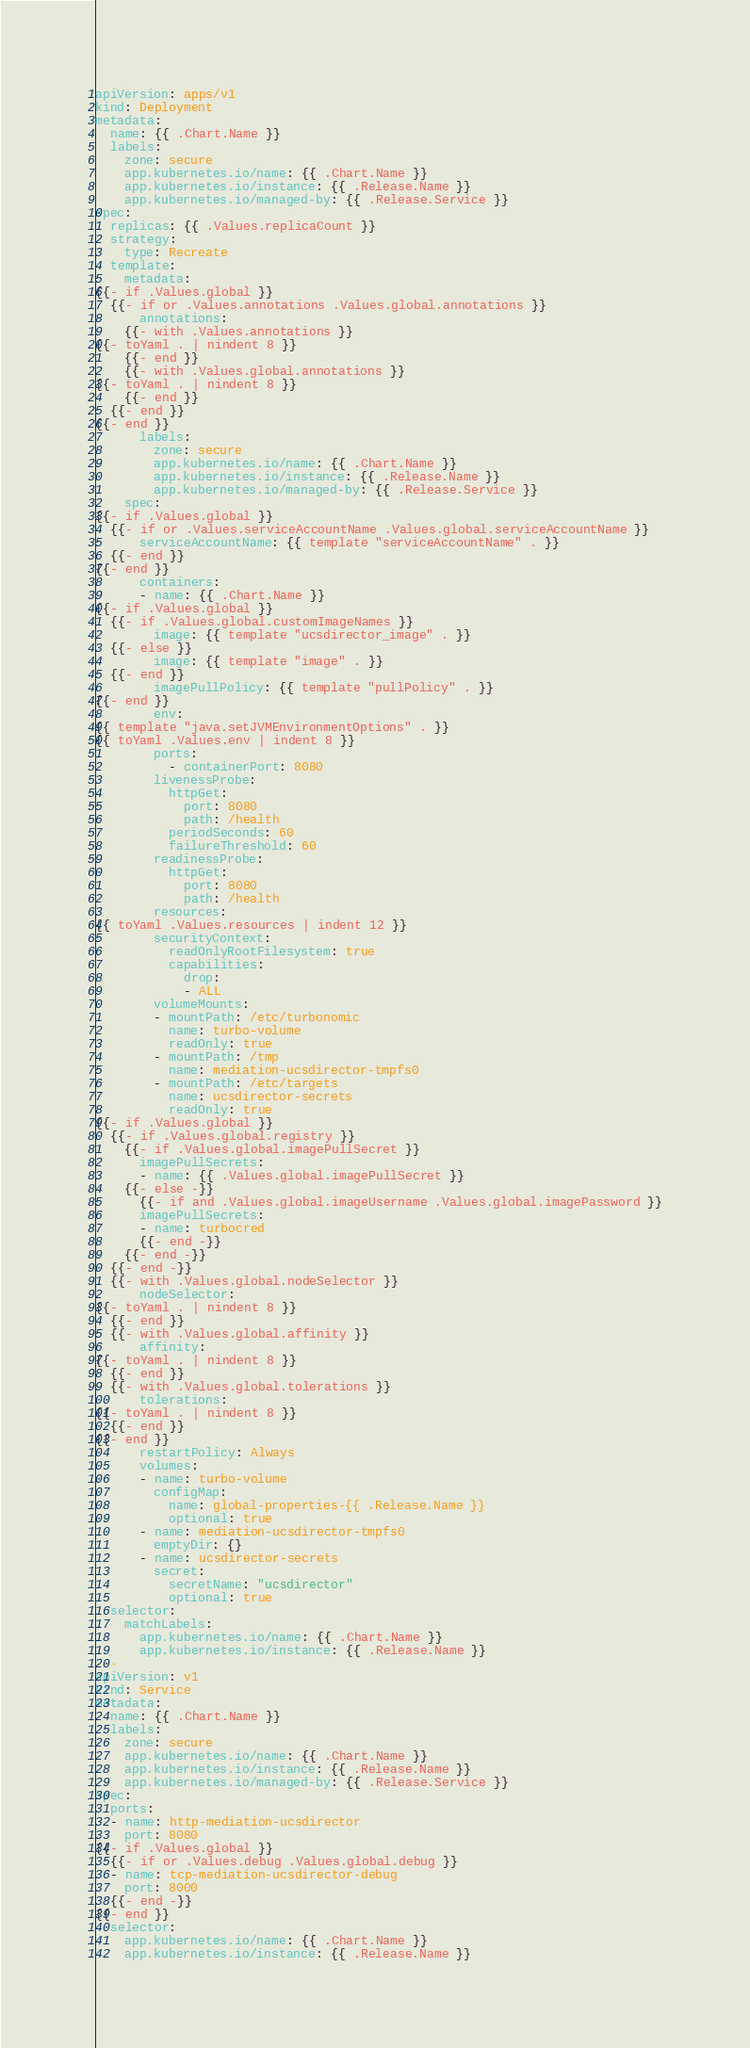<code> <loc_0><loc_0><loc_500><loc_500><_YAML_>apiVersion: apps/v1
kind: Deployment
metadata:
  name: {{ .Chart.Name }}
  labels:
    zone: secure
    app.kubernetes.io/name: {{ .Chart.Name }}
    app.kubernetes.io/instance: {{ .Release.Name }}
    app.kubernetes.io/managed-by: {{ .Release.Service }}
spec:
  replicas: {{ .Values.replicaCount }}
  strategy:
    type: Recreate
  template:
    metadata:
{{- if .Values.global }}
  {{- if or .Values.annotations .Values.global.annotations }}
      annotations:
    {{- with .Values.annotations }}
{{- toYaml . | nindent 8 }}
    {{- end }}
    {{- with .Values.global.annotations }}
{{- toYaml . | nindent 8 }}
    {{- end }}
  {{- end }}
{{- end }}
      labels:
        zone: secure
        app.kubernetes.io/name: {{ .Chart.Name }}
        app.kubernetes.io/instance: {{ .Release.Name }}
        app.kubernetes.io/managed-by: {{ .Release.Service }}
    spec:
{{- if .Values.global }}
  {{- if or .Values.serviceAccountName .Values.global.serviceAccountName }}
      serviceAccountName: {{ template "serviceAccountName" . }}
  {{- end }}
{{- end }}
      containers:
      - name: {{ .Chart.Name }}
{{- if .Values.global }}
  {{- if .Values.global.customImageNames }}
        image: {{ template "ucsdirector_image" . }}
  {{- else }}
        image: {{ template "image" . }}
  {{- end }}
        imagePullPolicy: {{ template "pullPolicy" . }}
{{- end }}
        env:
{{ template "java.setJVMEnvironmentOptions" . }}
{{ toYaml .Values.env | indent 8 }}
        ports:
          - containerPort: 8080
        livenessProbe:
          httpGet:
            port: 8080
            path: /health
          periodSeconds: 60
          failureThreshold: 60
        readinessProbe:
          httpGet:
            port: 8080
            path: /health
        resources:
{{ toYaml .Values.resources | indent 12 }}
        securityContext:
          readOnlyRootFilesystem: true
          capabilities:
            drop:
            - ALL
        volumeMounts:
        - mountPath: /etc/turbonomic
          name: turbo-volume
          readOnly: true
        - mountPath: /tmp
          name: mediation-ucsdirector-tmpfs0
        - mountPath: /etc/targets
          name: ucsdirector-secrets
          readOnly: true
{{- if .Values.global }}
  {{- if .Values.global.registry }}
    {{- if .Values.global.imagePullSecret }}
      imagePullSecrets:
      - name: {{ .Values.global.imagePullSecret }}
    {{- else -}}
      {{- if and .Values.global.imageUsername .Values.global.imagePassword }}
      imagePullSecrets:
      - name: turbocred
      {{- end -}}
    {{- end -}}
  {{- end -}}
  {{- with .Values.global.nodeSelector }}
      nodeSelector:
{{- toYaml . | nindent 8 }}
  {{- end }}
  {{- with .Values.global.affinity }}
      affinity:
{{- toYaml . | nindent 8 }}
  {{- end }}
  {{- with .Values.global.tolerations }}
      tolerations:
{{- toYaml . | nindent 8 }}
  {{- end }}
{{- end }}
      restartPolicy: Always
      volumes:
      - name: turbo-volume
        configMap:
          name: global-properties-{{ .Release.Name }}
          optional: true
      - name: mediation-ucsdirector-tmpfs0
        emptyDir: {}
      - name: ucsdirector-secrets
        secret:
          secretName: "ucsdirector"
          optional: true
  selector:
    matchLabels:
      app.kubernetes.io/name: {{ .Chart.Name }}
      app.kubernetes.io/instance: {{ .Release.Name }}
---
apiVersion: v1
kind: Service
metadata:
  name: {{ .Chart.Name }}
  labels:
    zone: secure
    app.kubernetes.io/name: {{ .Chart.Name }}
    app.kubernetes.io/instance: {{ .Release.Name }}
    app.kubernetes.io/managed-by: {{ .Release.Service }}
spec:
  ports:
  - name: http-mediation-ucsdirector
    port: 8080
{{- if .Values.global }}
  {{- if or .Values.debug .Values.global.debug }}
  - name: tcp-mediation-ucsdirector-debug
    port: 8000
  {{- end -}}
{{- end }}
  selector:
    app.kubernetes.io/name: {{ .Chart.Name }}
    app.kubernetes.io/instance: {{ .Release.Name }}
</code> 